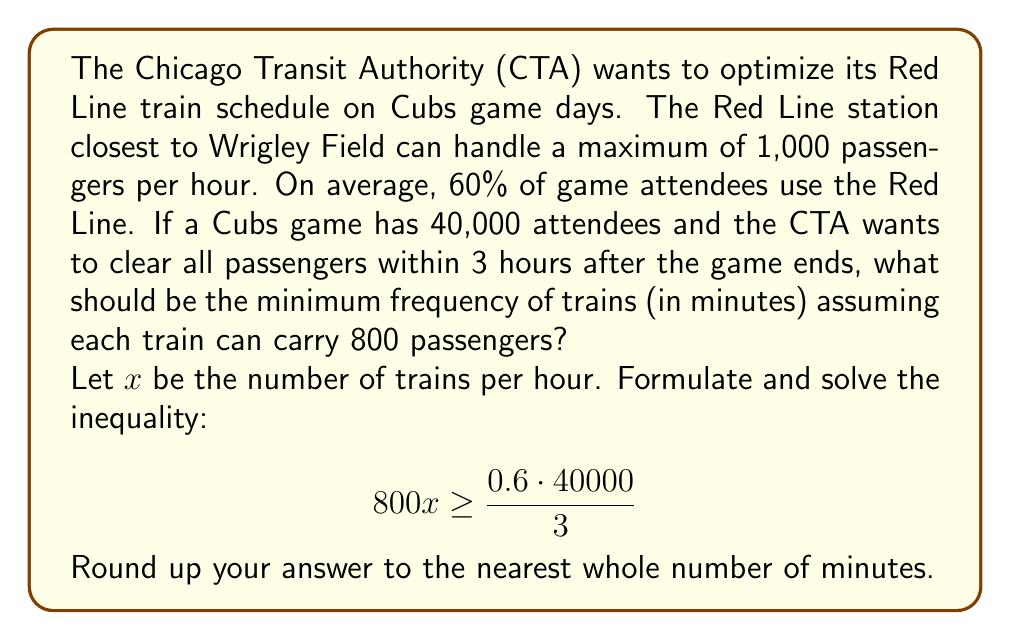Show me your answer to this math problem. To solve this problem, we'll follow these steps:

1) First, let's calculate the number of passengers that need to be transported:
   60% of 40,000 = $0.6 \cdot 40000 = 24000$ passengers

2) These passengers need to be cleared in 3 hours, so per hour we need to transport:
   $\frac{24000}{3} = 8000$ passengers per hour

3) Let $x$ be the number of trains per hour. Each train carries 800 passengers, so we can set up the inequality:
   $$ 800x \geq 8000 $$

4) Solve for $x$:
   $$ x \geq \frac{8000}{800} = 10 $$

5) This means we need at least 10 trains per hour.

6) To convert this to frequency in minutes, we divide 60 minutes by the number of trains:
   $$ \frac{60}{10} = 6 \text{ minutes} $$

Therefore, trains should run at least every 6 minutes to accommodate the game crowd within the given constraints.

Note: We don't need to round up in this case as 6 is already a whole number.
Answer: Trains should run every 6 minutes. 